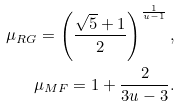<formula> <loc_0><loc_0><loc_500><loc_500>\mu _ { R G } = \left ( \frac { \sqrt { 5 } + 1 } { 2 } \right ) ^ { \frac { 1 } { u - 1 } } , \\ \mu _ { M F } = 1 + \frac { 2 } { 3 u - 3 } .</formula> 